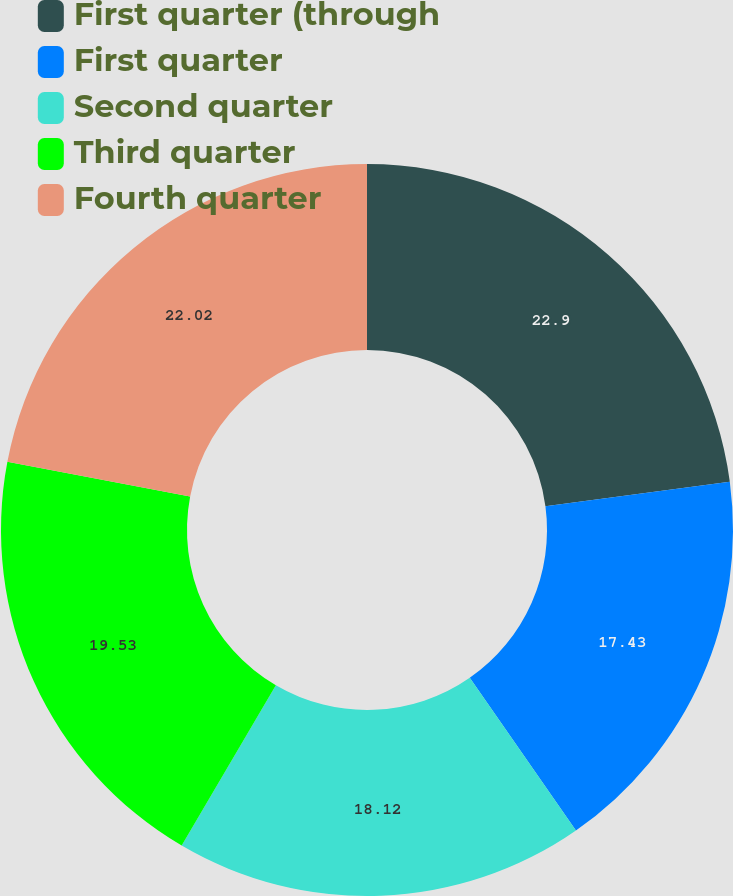<chart> <loc_0><loc_0><loc_500><loc_500><pie_chart><fcel>First quarter (through<fcel>First quarter<fcel>Second quarter<fcel>Third quarter<fcel>Fourth quarter<nl><fcel>22.9%<fcel>17.43%<fcel>18.12%<fcel>19.53%<fcel>22.02%<nl></chart> 